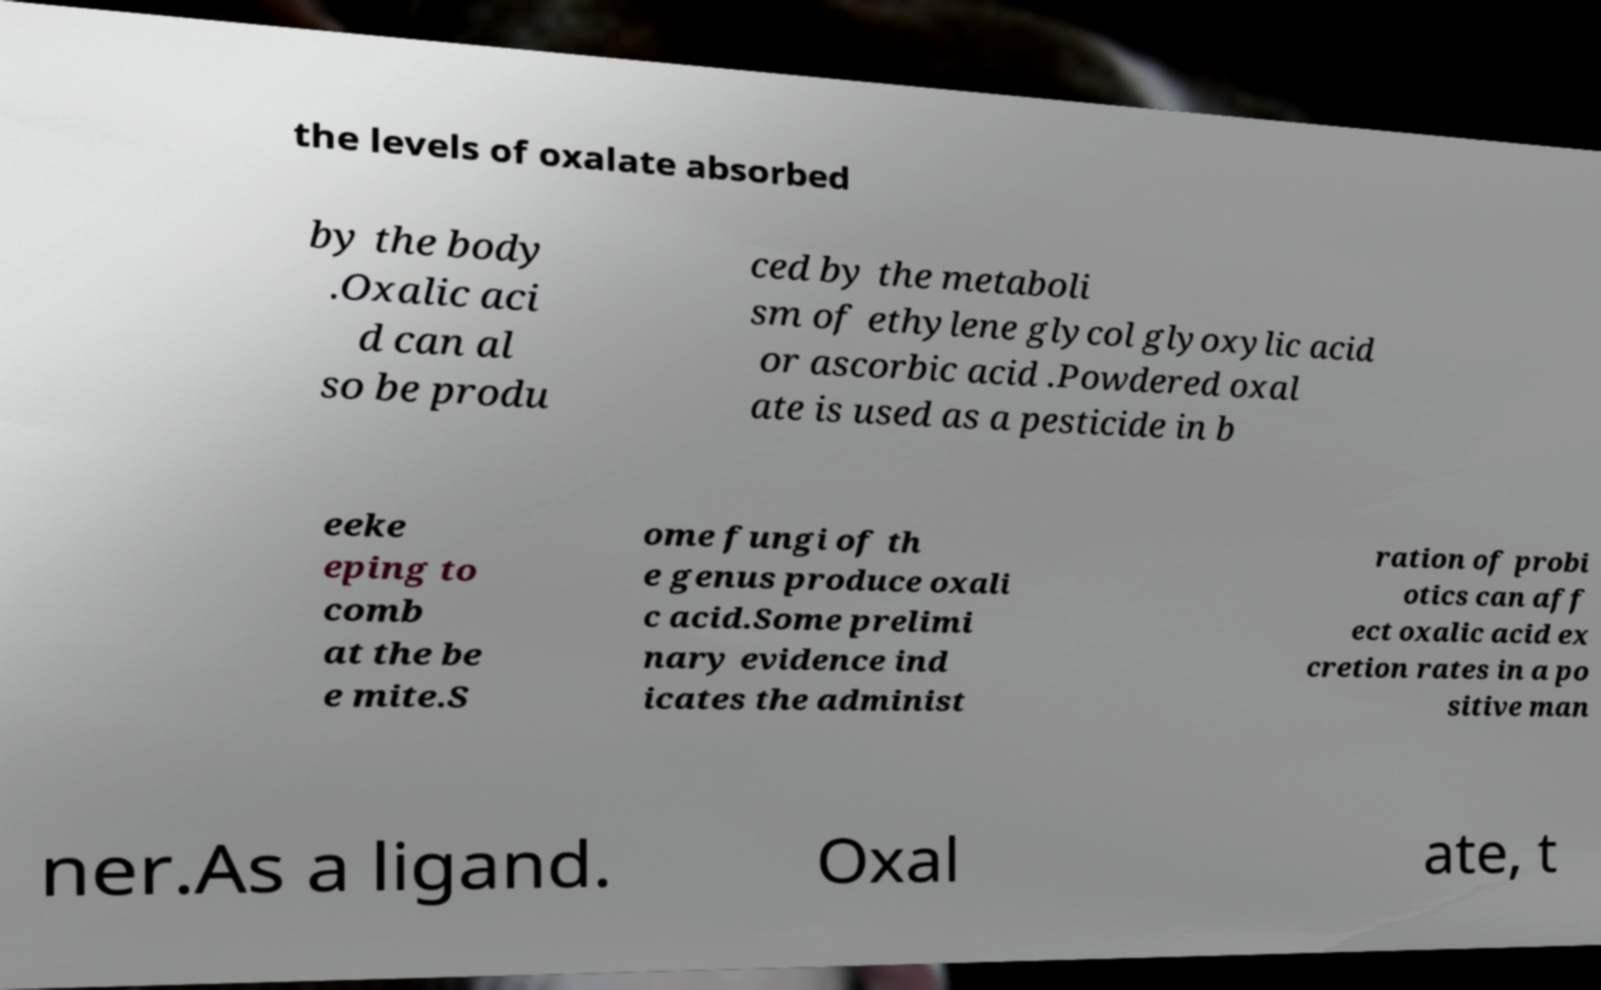For documentation purposes, I need the text within this image transcribed. Could you provide that? the levels of oxalate absorbed by the body .Oxalic aci d can al so be produ ced by the metaboli sm of ethylene glycol glyoxylic acid or ascorbic acid .Powdered oxal ate is used as a pesticide in b eeke eping to comb at the be e mite.S ome fungi of th e genus produce oxali c acid.Some prelimi nary evidence ind icates the administ ration of probi otics can aff ect oxalic acid ex cretion rates in a po sitive man ner.As a ligand. Oxal ate, t 